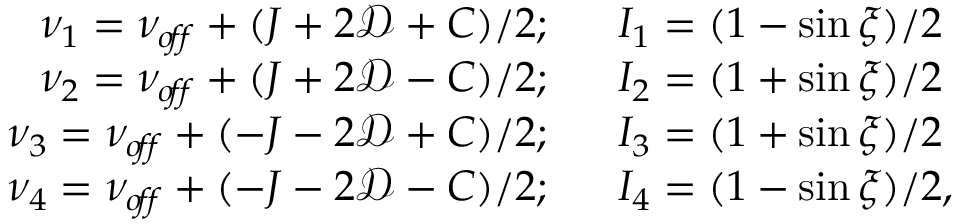Convert formula to latex. <formula><loc_0><loc_0><loc_500><loc_500>\begin{array} { r l } { \nu _ { 1 } = \nu _ { o \, f \, f } + ( J + 2 \mathcal { D } + C ) / 2 ; } & { I _ { 1 } = ( 1 - \sin \xi ) / 2 } \\ { \nu _ { 2 } = \nu _ { o \, f \, f } + ( J + 2 \mathcal { D } - C ) / 2 ; } & { I _ { 2 } = ( 1 + \sin \xi ) / 2 } \\ { \nu _ { 3 } = \nu _ { o \, f \, f } + ( - J - 2 \mathcal { D } + C ) / 2 ; } & { I _ { 3 } = ( 1 + \sin \xi ) / 2 } \\ { \nu _ { 4 } = \nu _ { o \, f \, f } + ( - J - 2 \mathcal { D } - C ) / 2 ; } & { I _ { 4 } = ( 1 - \sin \xi ) / 2 , } \end{array}</formula> 